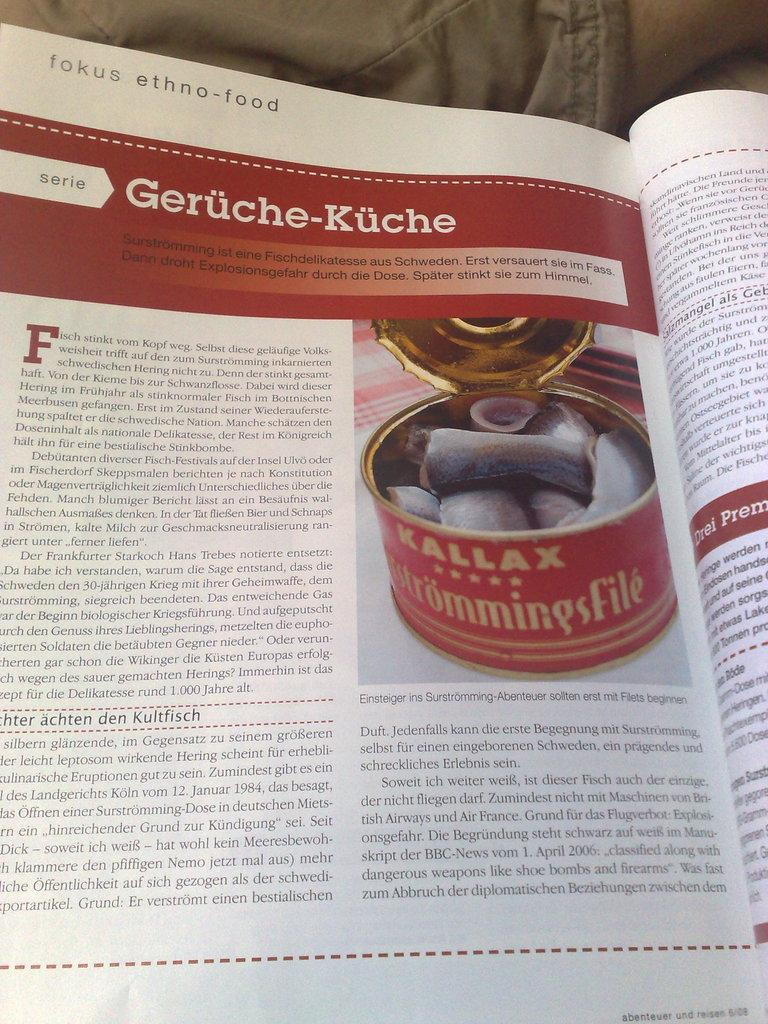<image>
Write a terse but informative summary of the picture. A magazine article about something called Geruche Kuche. 